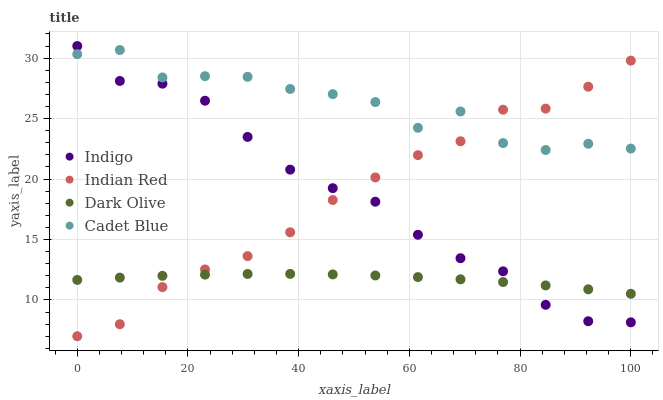Does Dark Olive have the minimum area under the curve?
Answer yes or no. Yes. Does Cadet Blue have the maximum area under the curve?
Answer yes or no. Yes. Does Indigo have the minimum area under the curve?
Answer yes or no. No. Does Indigo have the maximum area under the curve?
Answer yes or no. No. Is Dark Olive the smoothest?
Answer yes or no. Yes. Is Cadet Blue the roughest?
Answer yes or no. Yes. Is Indigo the smoothest?
Answer yes or no. No. Is Indigo the roughest?
Answer yes or no. No. Does Indian Red have the lowest value?
Answer yes or no. Yes. Does Dark Olive have the lowest value?
Answer yes or no. No. Does Indigo have the highest value?
Answer yes or no. Yes. Does Dark Olive have the highest value?
Answer yes or no. No. Is Dark Olive less than Cadet Blue?
Answer yes or no. Yes. Is Cadet Blue greater than Dark Olive?
Answer yes or no. Yes. Does Dark Olive intersect Indian Red?
Answer yes or no. Yes. Is Dark Olive less than Indian Red?
Answer yes or no. No. Is Dark Olive greater than Indian Red?
Answer yes or no. No. Does Dark Olive intersect Cadet Blue?
Answer yes or no. No. 